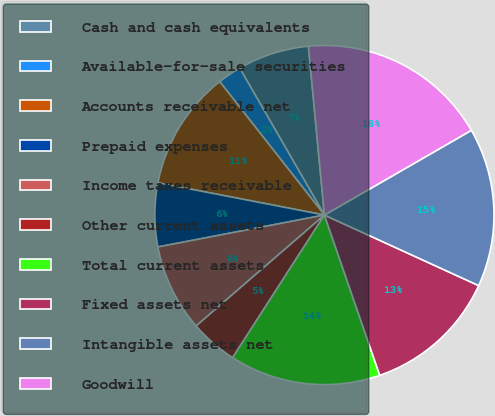Convert chart. <chart><loc_0><loc_0><loc_500><loc_500><pie_chart><fcel>Cash and cash equivalents<fcel>Available-for-sale securities<fcel>Accounts receivable net<fcel>Prepaid expenses<fcel>Income taxes receivable<fcel>Other current assets<fcel>Total current assets<fcel>Fixed assets net<fcel>Intangible assets net<fcel>Goodwill<nl><fcel>6.82%<fcel>2.27%<fcel>11.36%<fcel>6.06%<fcel>8.33%<fcel>4.55%<fcel>14.39%<fcel>12.88%<fcel>15.15%<fcel>18.18%<nl></chart> 